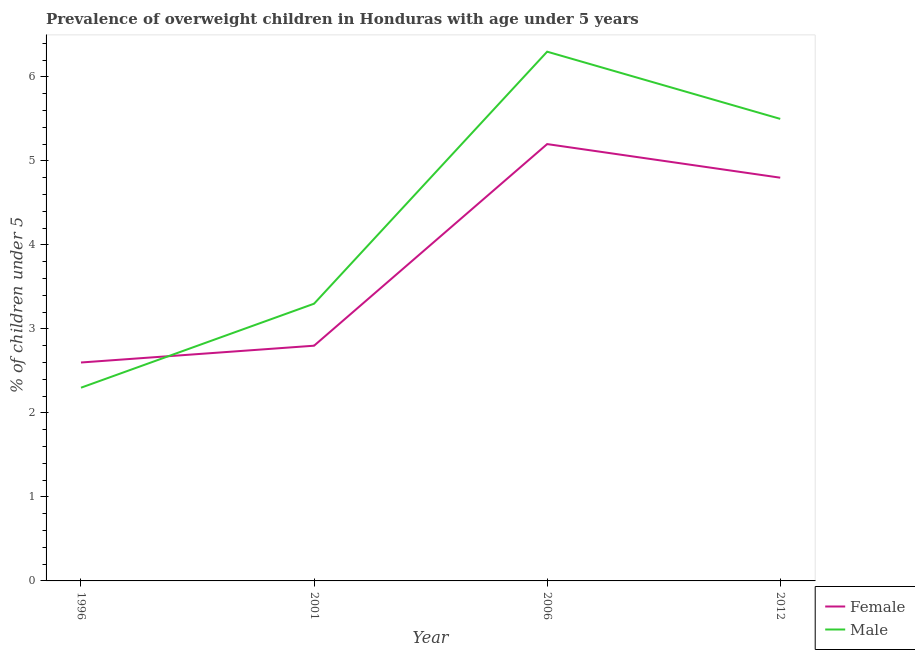Does the line corresponding to percentage of obese female children intersect with the line corresponding to percentage of obese male children?
Make the answer very short. Yes. What is the percentage of obese male children in 2012?
Your answer should be very brief. 5.5. Across all years, what is the maximum percentage of obese male children?
Your response must be concise. 6.3. Across all years, what is the minimum percentage of obese female children?
Keep it short and to the point. 2.6. In which year was the percentage of obese female children maximum?
Ensure brevity in your answer.  2006. In which year was the percentage of obese female children minimum?
Your answer should be compact. 1996. What is the total percentage of obese male children in the graph?
Your answer should be very brief. 17.4. What is the difference between the percentage of obese female children in 1996 and that in 2001?
Keep it short and to the point. -0.2. What is the difference between the percentage of obese female children in 2012 and the percentage of obese male children in 2001?
Provide a short and direct response. 1.5. What is the average percentage of obese male children per year?
Provide a succinct answer. 4.35. In the year 1996, what is the difference between the percentage of obese female children and percentage of obese male children?
Offer a very short reply. 0.3. What is the ratio of the percentage of obese female children in 1996 to that in 2012?
Provide a succinct answer. 0.54. Is the percentage of obese female children in 1996 less than that in 2001?
Make the answer very short. Yes. What is the difference between the highest and the second highest percentage of obese male children?
Provide a short and direct response. 0.8. What is the difference between the highest and the lowest percentage of obese female children?
Offer a very short reply. 2.6. Is the sum of the percentage of obese male children in 1996 and 2001 greater than the maximum percentage of obese female children across all years?
Give a very brief answer. Yes. Is the percentage of obese female children strictly greater than the percentage of obese male children over the years?
Your answer should be compact. No. How many years are there in the graph?
Ensure brevity in your answer.  4. Are the values on the major ticks of Y-axis written in scientific E-notation?
Give a very brief answer. No. Does the graph contain any zero values?
Make the answer very short. No. Where does the legend appear in the graph?
Provide a short and direct response. Bottom right. How are the legend labels stacked?
Offer a terse response. Vertical. What is the title of the graph?
Your response must be concise. Prevalence of overweight children in Honduras with age under 5 years. Does "Female labor force" appear as one of the legend labels in the graph?
Your answer should be very brief. No. What is the label or title of the Y-axis?
Your response must be concise.  % of children under 5. What is the  % of children under 5 of Female in 1996?
Offer a terse response. 2.6. What is the  % of children under 5 in Male in 1996?
Offer a terse response. 2.3. What is the  % of children under 5 in Female in 2001?
Provide a succinct answer. 2.8. What is the  % of children under 5 of Male in 2001?
Your response must be concise. 3.3. What is the  % of children under 5 in Female in 2006?
Your answer should be very brief. 5.2. What is the  % of children under 5 in Male in 2006?
Keep it short and to the point. 6.3. What is the  % of children under 5 in Female in 2012?
Ensure brevity in your answer.  4.8. Across all years, what is the maximum  % of children under 5 in Female?
Ensure brevity in your answer.  5.2. Across all years, what is the maximum  % of children under 5 of Male?
Your answer should be very brief. 6.3. Across all years, what is the minimum  % of children under 5 in Female?
Your answer should be compact. 2.6. Across all years, what is the minimum  % of children under 5 in Male?
Provide a short and direct response. 2.3. What is the total  % of children under 5 of Male in the graph?
Your answer should be compact. 17.4. What is the difference between the  % of children under 5 of Female in 1996 and that in 2012?
Your answer should be very brief. -2.2. What is the difference between the  % of children under 5 of Male in 1996 and that in 2012?
Give a very brief answer. -3.2. What is the difference between the  % of children under 5 of Male in 2001 and that in 2012?
Your answer should be very brief. -2.2. What is the difference between the  % of children under 5 of Male in 2006 and that in 2012?
Make the answer very short. 0.8. What is the difference between the  % of children under 5 in Female in 1996 and the  % of children under 5 in Male in 2001?
Keep it short and to the point. -0.7. What is the difference between the  % of children under 5 in Female in 1996 and the  % of children under 5 in Male in 2012?
Ensure brevity in your answer.  -2.9. What is the difference between the  % of children under 5 in Female in 2001 and the  % of children under 5 in Male in 2006?
Offer a terse response. -3.5. What is the average  % of children under 5 in Female per year?
Ensure brevity in your answer.  3.85. What is the average  % of children under 5 of Male per year?
Make the answer very short. 4.35. In the year 1996, what is the difference between the  % of children under 5 in Female and  % of children under 5 in Male?
Provide a succinct answer. 0.3. In the year 2012, what is the difference between the  % of children under 5 of Female and  % of children under 5 of Male?
Offer a very short reply. -0.7. What is the ratio of the  % of children under 5 in Male in 1996 to that in 2001?
Keep it short and to the point. 0.7. What is the ratio of the  % of children under 5 in Female in 1996 to that in 2006?
Keep it short and to the point. 0.5. What is the ratio of the  % of children under 5 of Male in 1996 to that in 2006?
Your answer should be compact. 0.37. What is the ratio of the  % of children under 5 in Female in 1996 to that in 2012?
Offer a terse response. 0.54. What is the ratio of the  % of children under 5 in Male in 1996 to that in 2012?
Your answer should be very brief. 0.42. What is the ratio of the  % of children under 5 of Female in 2001 to that in 2006?
Your response must be concise. 0.54. What is the ratio of the  % of children under 5 in Male in 2001 to that in 2006?
Ensure brevity in your answer.  0.52. What is the ratio of the  % of children under 5 in Female in 2001 to that in 2012?
Ensure brevity in your answer.  0.58. What is the ratio of the  % of children under 5 in Male in 2001 to that in 2012?
Keep it short and to the point. 0.6. What is the ratio of the  % of children under 5 in Female in 2006 to that in 2012?
Your answer should be very brief. 1.08. What is the ratio of the  % of children under 5 in Male in 2006 to that in 2012?
Your answer should be very brief. 1.15. What is the difference between the highest and the second highest  % of children under 5 in Male?
Make the answer very short. 0.8. What is the difference between the highest and the lowest  % of children under 5 of Male?
Ensure brevity in your answer.  4. 